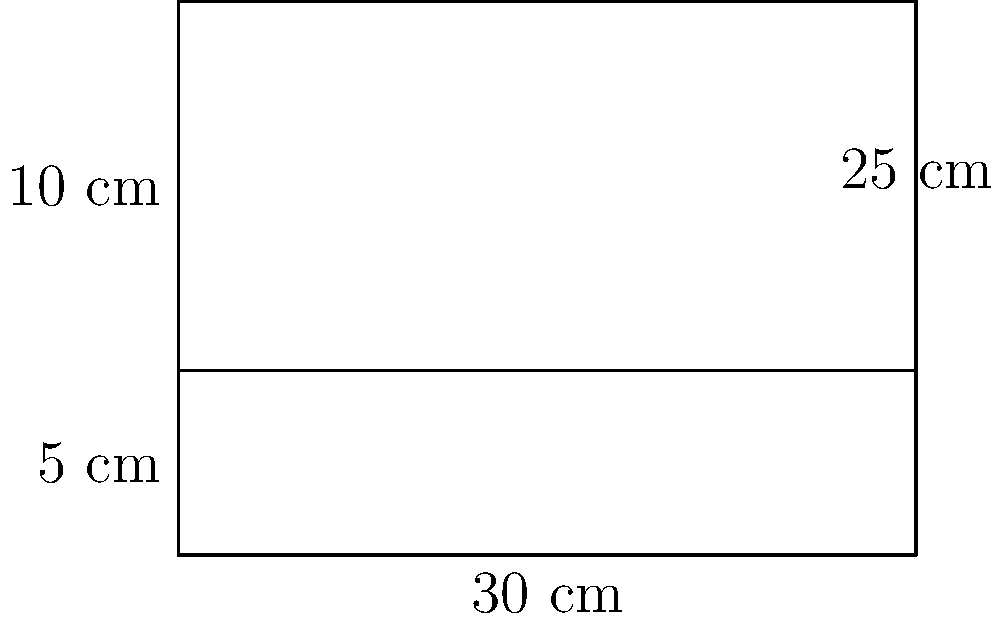You're designing new eco-friendly takeout containers for your restaurant. The container is a rectangular prism with a length of 30 cm, a width of 25 cm, and a height of 15 cm. To reduce material usage, you decide to lower the height of the container by 5 cm. What is the reduction in surface area (in cm²) of the new container compared to the original design? Let's approach this step-by-step:

1) First, let's calculate the surface area of the original container:
   
   Surface Area = 2(length × width + length × height + width × height)
   
   $SA_{original} = 2(30 \times 25 + 30 \times 15 + 25 \times 15)$
   $= 2(750 + 450 + 375) = 2(1575) = 3150$ cm²

2) Now, let's calculate the surface area of the new container with reduced height:
   
   New height = 15 - 5 = 10 cm
   
   $SA_{new} = 2(30 \times 25 + 30 \times 10 + 25 \times 10)$
   $= 2(750 + 300 + 250) = 2(1300) = 2600$ cm²

3) The reduction in surface area is:
   
   $SA_{reduction} = SA_{original} - SA_{new}$
   $= 3150 - 2600 = 550$ cm²

Therefore, the reduction in surface area is 550 cm².
Answer: 550 cm² 